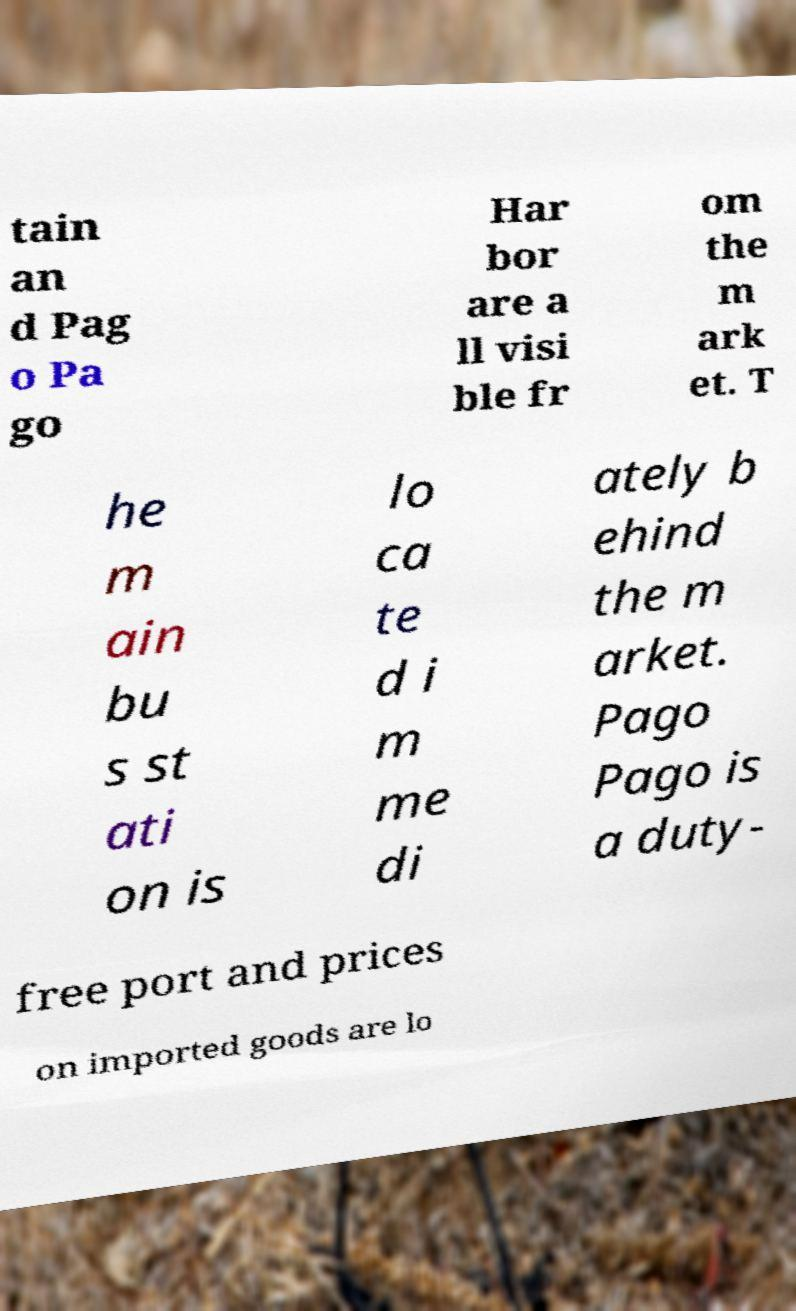Could you assist in decoding the text presented in this image and type it out clearly? tain an d Pag o Pa go Har bor are a ll visi ble fr om the m ark et. T he m ain bu s st ati on is lo ca te d i m me di ately b ehind the m arket. Pago Pago is a duty- free port and prices on imported goods are lo 